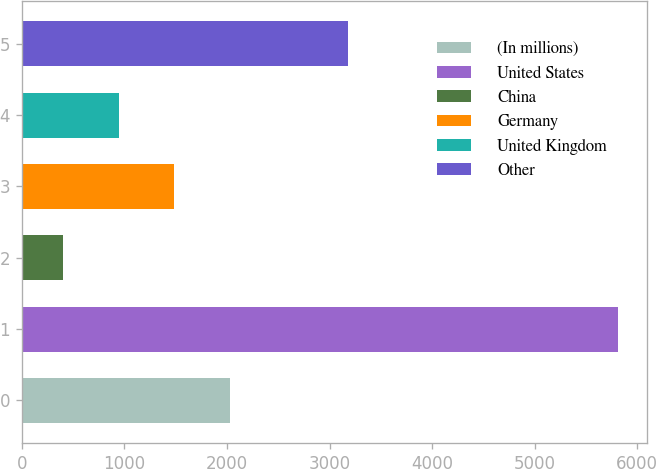<chart> <loc_0><loc_0><loc_500><loc_500><bar_chart><fcel>(In millions)<fcel>United States<fcel>China<fcel>Germany<fcel>United Kingdom<fcel>Other<nl><fcel>2025.75<fcel>5806.8<fcel>405.3<fcel>1485.6<fcel>945.45<fcel>3178.5<nl></chart> 